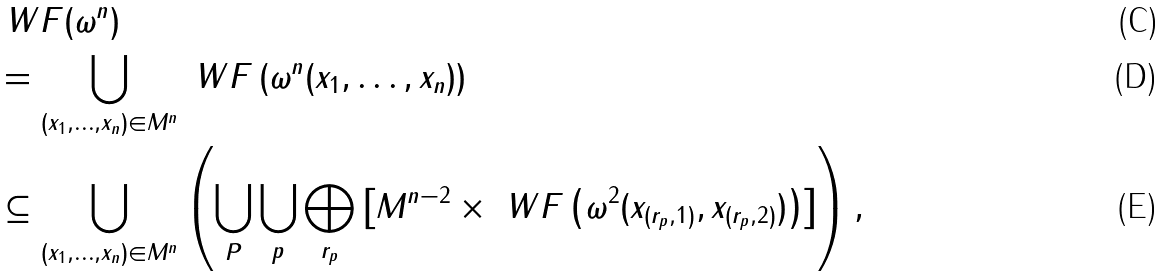Convert formula to latex. <formula><loc_0><loc_0><loc_500><loc_500>& \ W F ( \omega ^ { n } ) \\ & = \bigcup _ { ( x _ { 1 } , \dots , x _ { n } ) \in M ^ { n } } \ W F \left ( \omega ^ { n } ( x _ { 1 } , \dots , x _ { n } ) \right ) \\ & \subseteq \bigcup _ { ( x _ { 1 } , \dots , x _ { n } ) \in M ^ { n } } \left ( \bigcup _ { P } \bigcup _ { p } \bigoplus _ { r _ { p } } \left [ M ^ { n - 2 } \times \ W F \left ( \omega ^ { 2 } ( x _ { ( r _ { p } , 1 ) } , x _ { ( r _ { p } , 2 ) } ) \right ) \right ] \right ) ,</formula> 